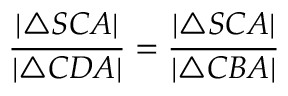<formula> <loc_0><loc_0><loc_500><loc_500>{ \frac { | \triangle S C A | } { | \triangle C D A | } } = { \frac { | \triangle S C A | } { | \triangle C B A | } }</formula> 